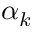<formula> <loc_0><loc_0><loc_500><loc_500>\alpha _ { k }</formula> 